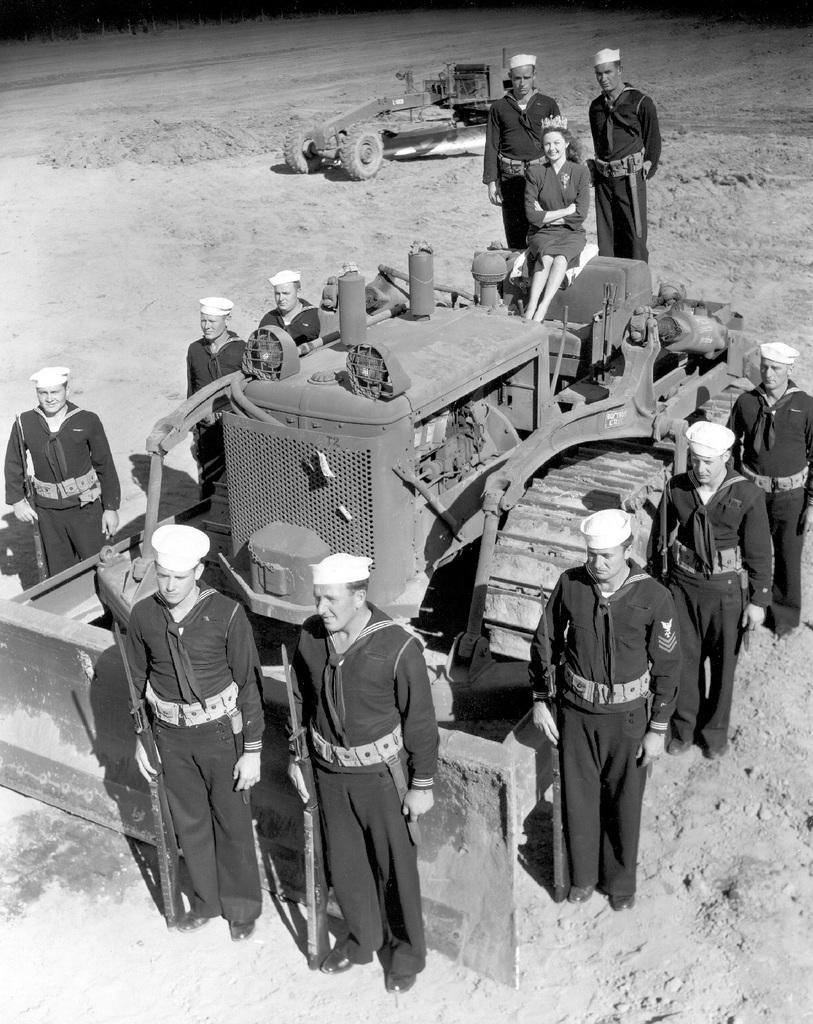Please provide a concise description of this image. There are people standing and these people holding guns. We can see vehicles on the surface. 